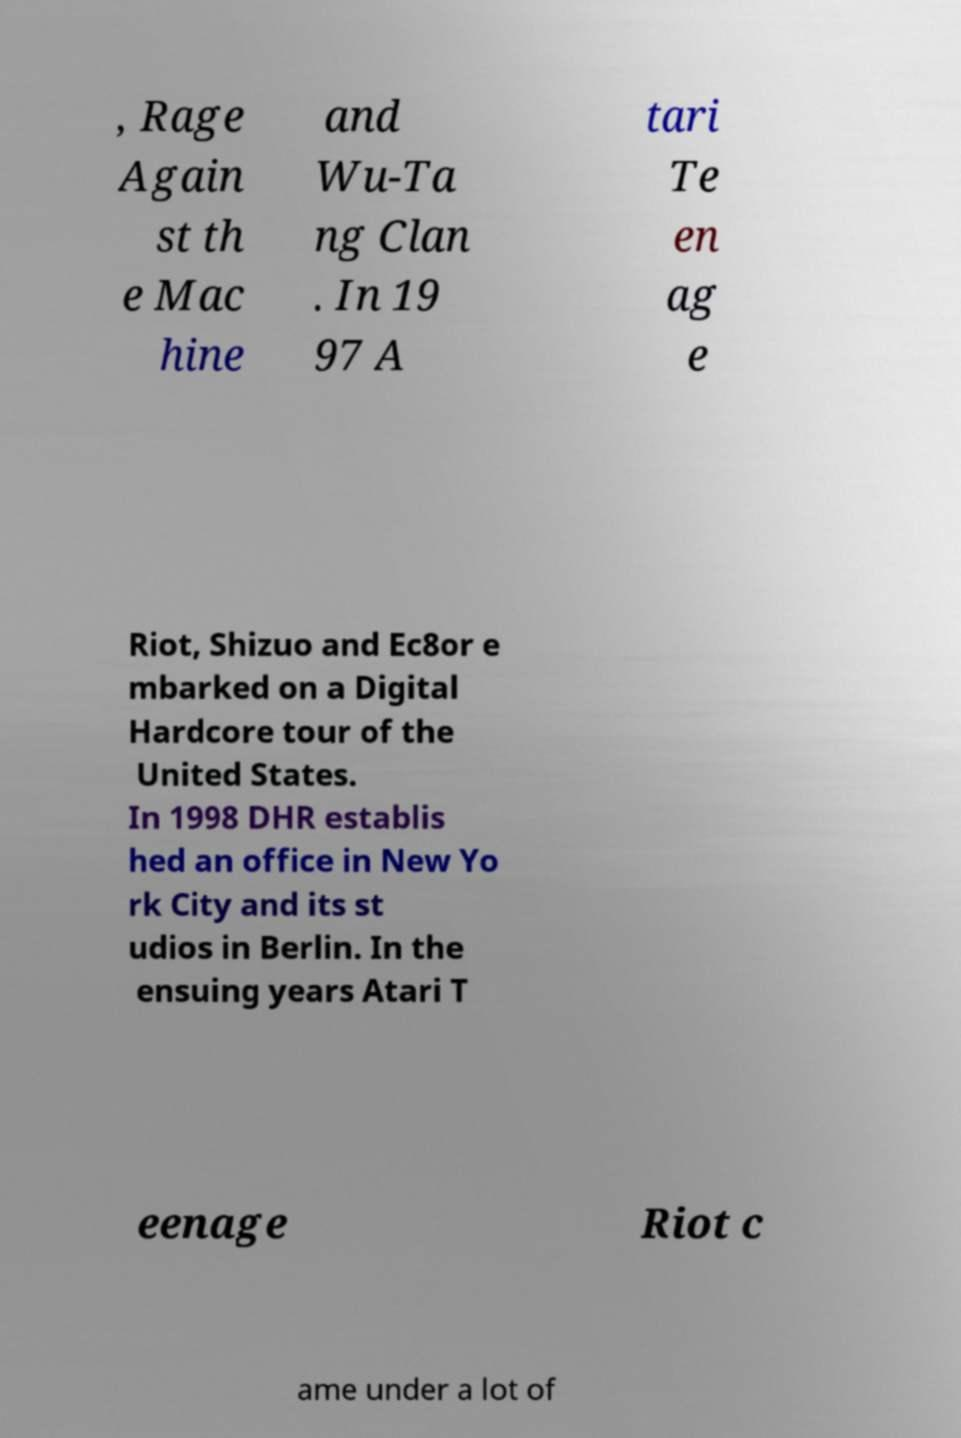Can you accurately transcribe the text from the provided image for me? , Rage Again st th e Mac hine and Wu-Ta ng Clan . In 19 97 A tari Te en ag e Riot, Shizuo and Ec8or e mbarked on a Digital Hardcore tour of the United States. In 1998 DHR establis hed an office in New Yo rk City and its st udios in Berlin. In the ensuing years Atari T eenage Riot c ame under a lot of 